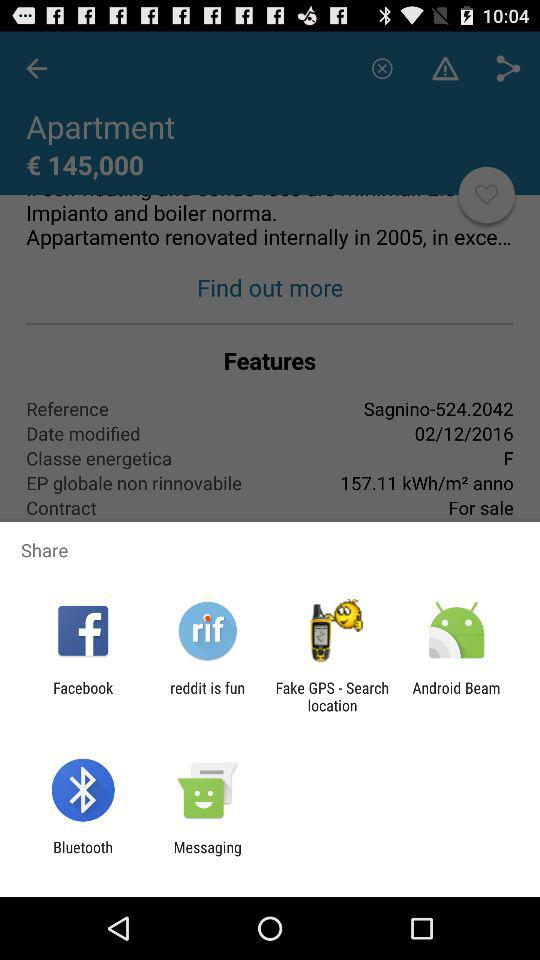What is the "Reference" given in the feature option?
Answer the question using a single word or phrase. It is Sagnino-524.2042. 